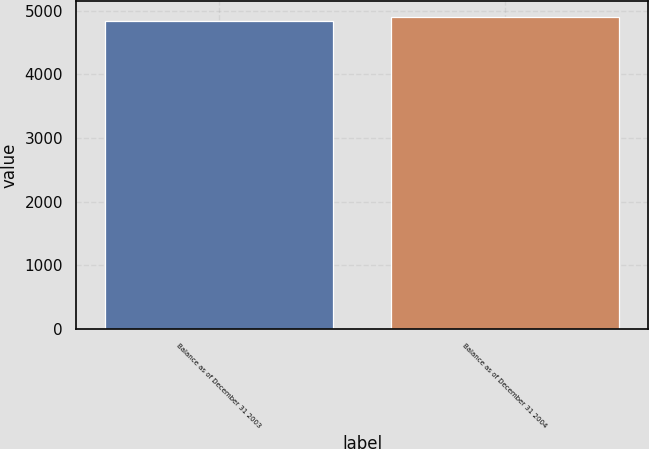<chart> <loc_0><loc_0><loc_500><loc_500><bar_chart><fcel>Balance as of December 31 2003<fcel>Balance as of December 31 2004<nl><fcel>4836<fcel>4905<nl></chart> 